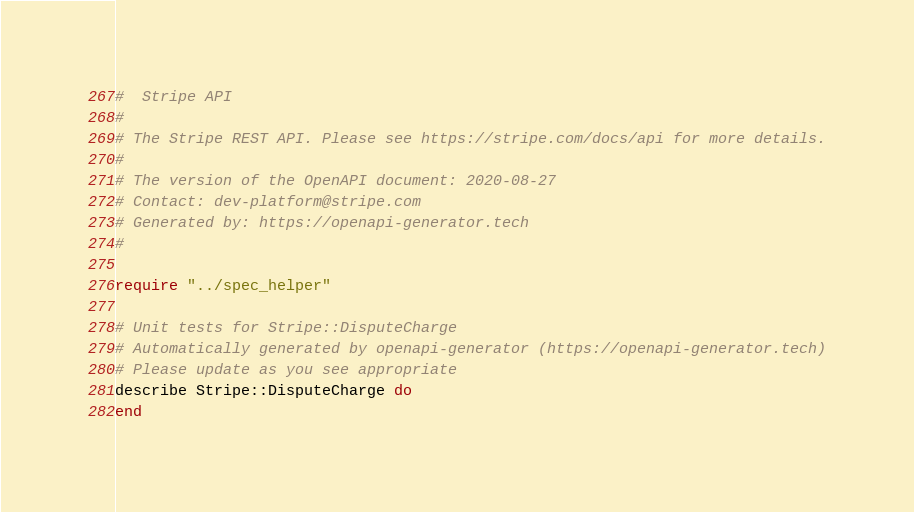Convert code to text. <code><loc_0><loc_0><loc_500><loc_500><_Crystal_>#  Stripe API
#
# The Stripe REST API. Please see https://stripe.com/docs/api for more details.
#
# The version of the OpenAPI document: 2020-08-27
# Contact: dev-platform@stripe.com
# Generated by: https://openapi-generator.tech
#

require "../spec_helper"

# Unit tests for Stripe::DisputeCharge
# Automatically generated by openapi-generator (https://openapi-generator.tech)
# Please update as you see appropriate
describe Stripe::DisputeCharge do
end
</code> 